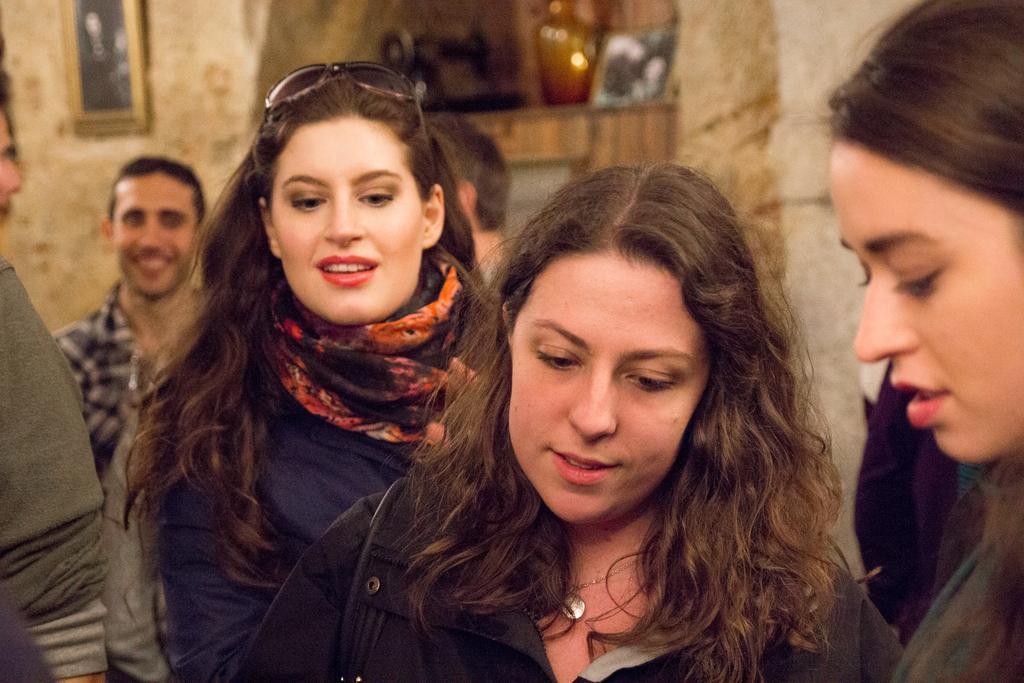How would you summarize this image in a sentence or two? In this image I can see three women standing and in the background I can see few other persons, the wall, a photo frame attached to the wall, a machine, a flower vase and few other objects. 